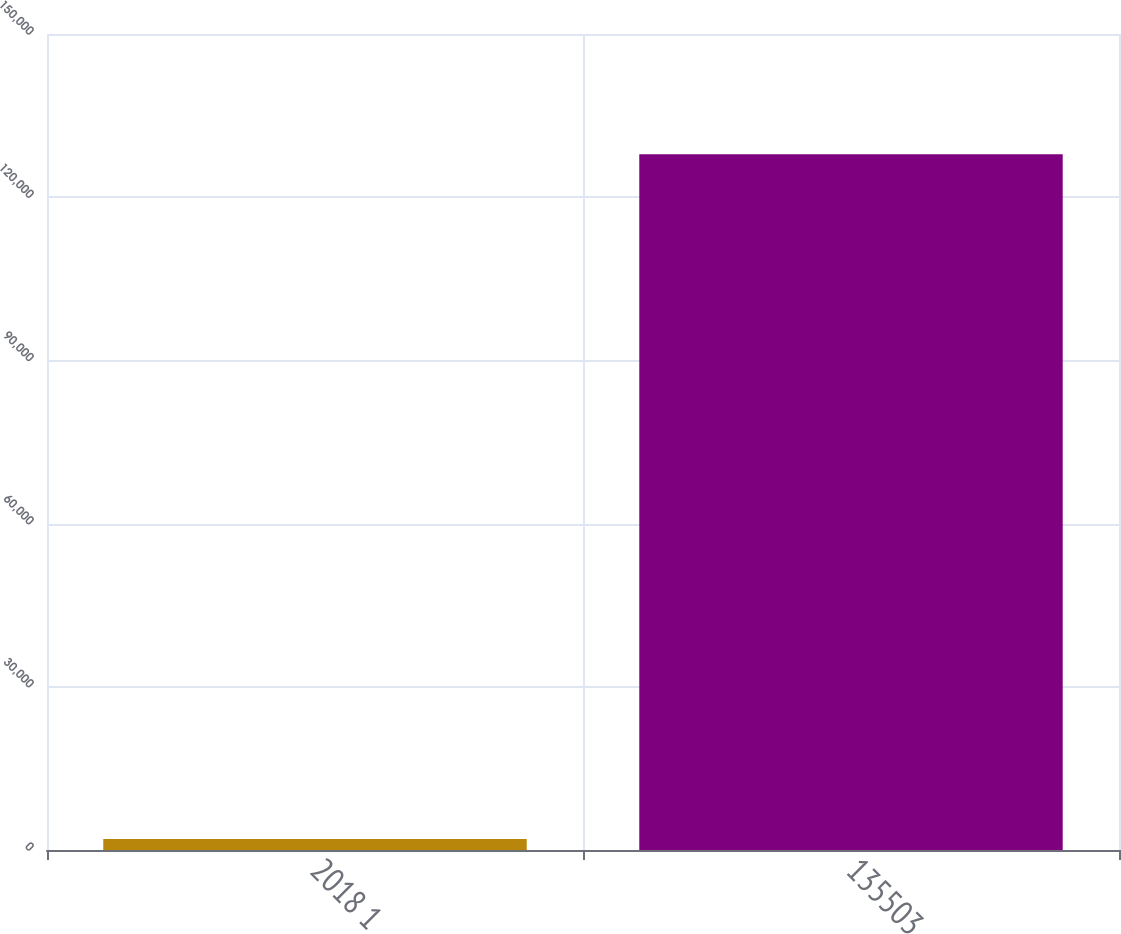Convert chart. <chart><loc_0><loc_0><loc_500><loc_500><bar_chart><fcel>2018 1<fcel>135503<nl><fcel>2017<fcel>127893<nl></chart> 